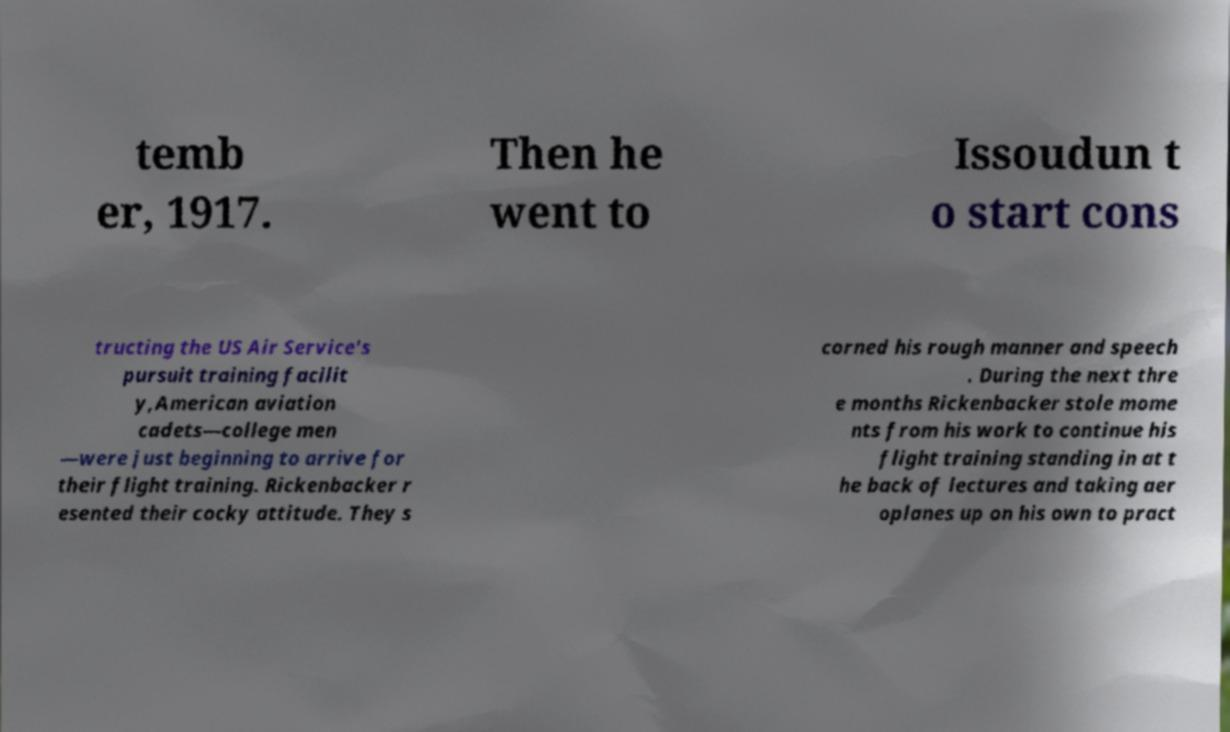Please identify and transcribe the text found in this image. temb er, 1917. Then he went to Issoudun t o start cons tructing the US Air Service's pursuit training facilit y,American aviation cadets—college men —were just beginning to arrive for their flight training. Rickenbacker r esented their cocky attitude. They s corned his rough manner and speech . During the next thre e months Rickenbacker stole mome nts from his work to continue his flight training standing in at t he back of lectures and taking aer oplanes up on his own to pract 